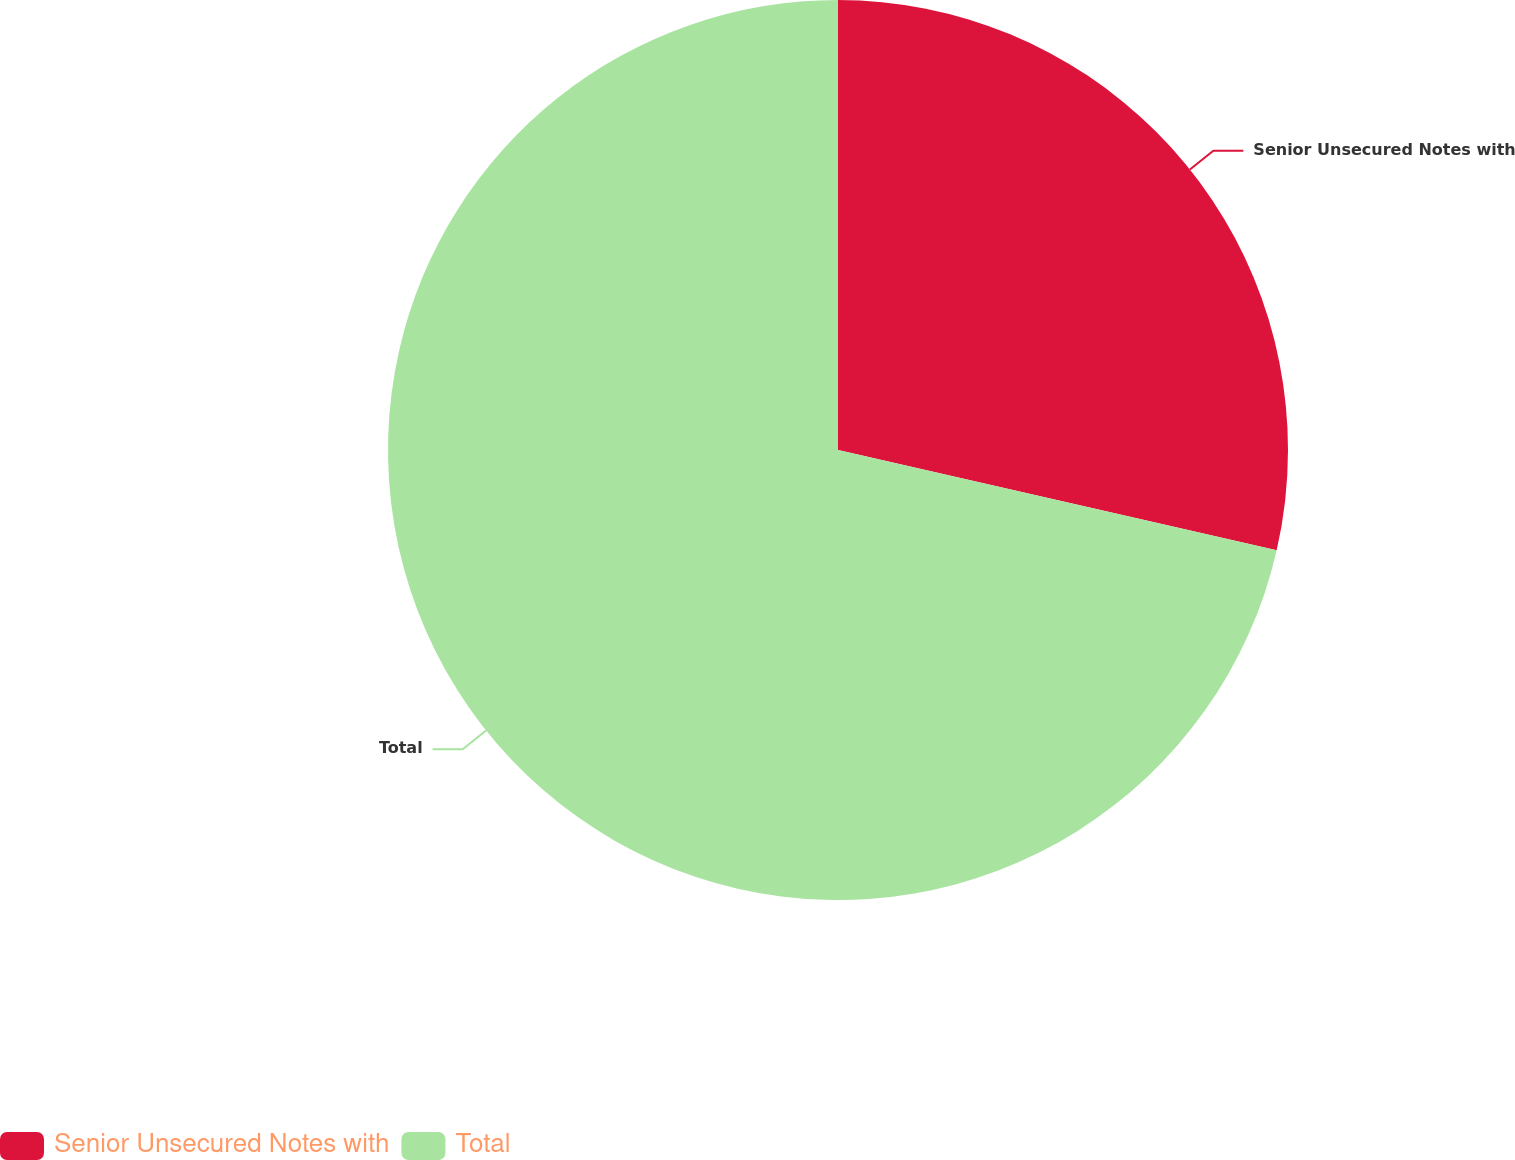<chart> <loc_0><loc_0><loc_500><loc_500><pie_chart><fcel>Senior Unsecured Notes with<fcel>Total<nl><fcel>28.58%<fcel>71.42%<nl></chart> 